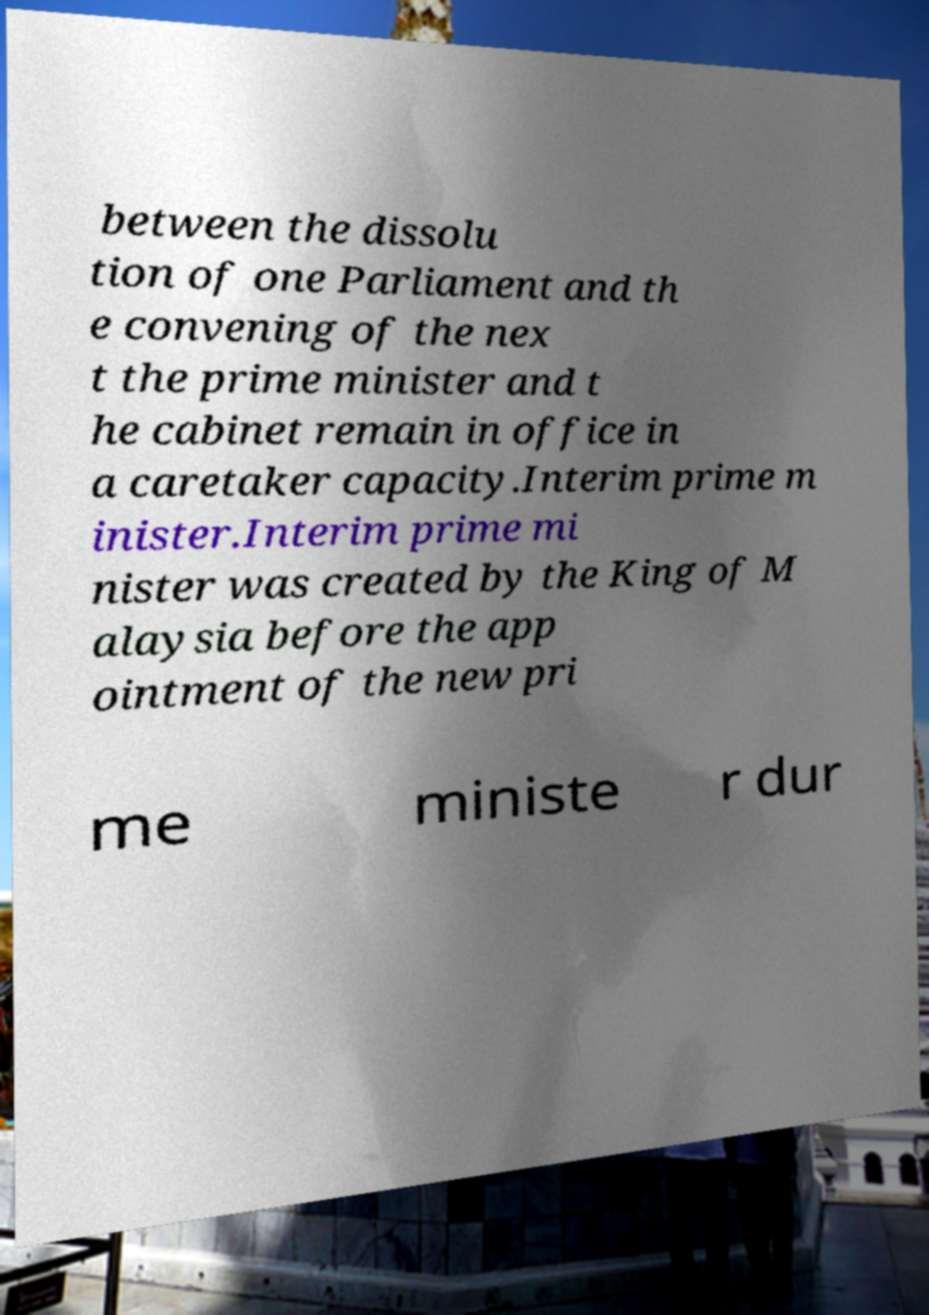Could you extract and type out the text from this image? between the dissolu tion of one Parliament and th e convening of the nex t the prime minister and t he cabinet remain in office in a caretaker capacity.Interim prime m inister.Interim prime mi nister was created by the King of M alaysia before the app ointment of the new pri me ministe r dur 